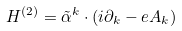<formula> <loc_0><loc_0><loc_500><loc_500>H ^ { ( 2 ) } = { \tilde { \alpha } } ^ { k } \cdot ( i \partial _ { k } - e A _ { k } )</formula> 